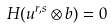<formula> <loc_0><loc_0><loc_500><loc_500>H ( u ^ { r , s } \otimes b ) = 0</formula> 